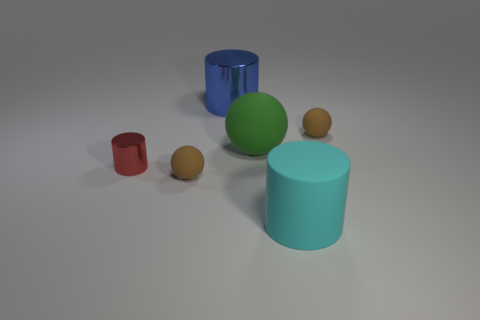What is the material of the red cylinder?
Keep it short and to the point. Metal. What number of things are small red metal objects or gray cylinders?
Offer a terse response. 1. Is the size of the brown rubber ball to the right of the blue object the same as the brown matte sphere in front of the tiny red cylinder?
Make the answer very short. Yes. How many other things are the same size as the blue thing?
Your response must be concise. 2. What number of things are either tiny matte things to the right of the large blue thing or brown things to the right of the large green matte ball?
Provide a short and direct response. 1. Is the material of the blue cylinder the same as the red cylinder that is left of the big blue shiny cylinder?
Ensure brevity in your answer.  Yes. How many other objects are there of the same shape as the large blue metallic object?
Offer a very short reply. 2. There is a big cylinder that is behind the large rubber object in front of the tiny ball in front of the red metal thing; what is it made of?
Provide a succinct answer. Metal. Are there the same number of blue metallic objects that are on the left side of the blue thing and green matte balls?
Provide a short and direct response. No. Is the tiny object that is right of the big blue shiny cylinder made of the same material as the large cylinder that is in front of the red shiny cylinder?
Your answer should be very brief. Yes. 